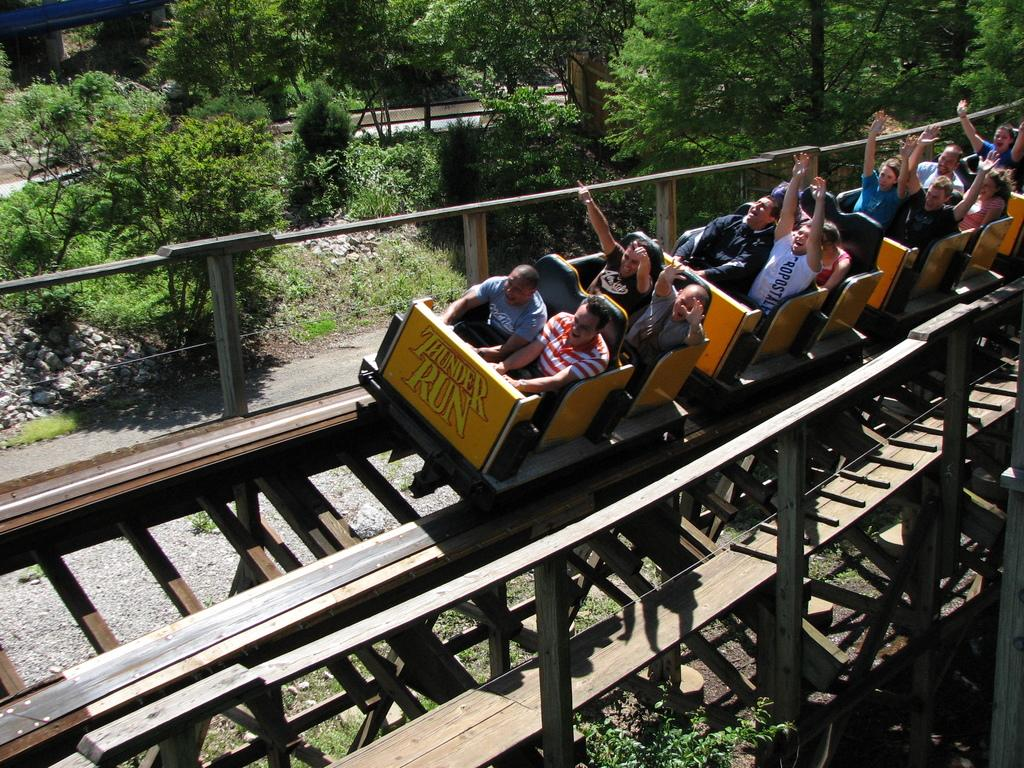<image>
Give a short and clear explanation of the subsequent image. People ride the Thunder Run roller coaster on a sunny day. 